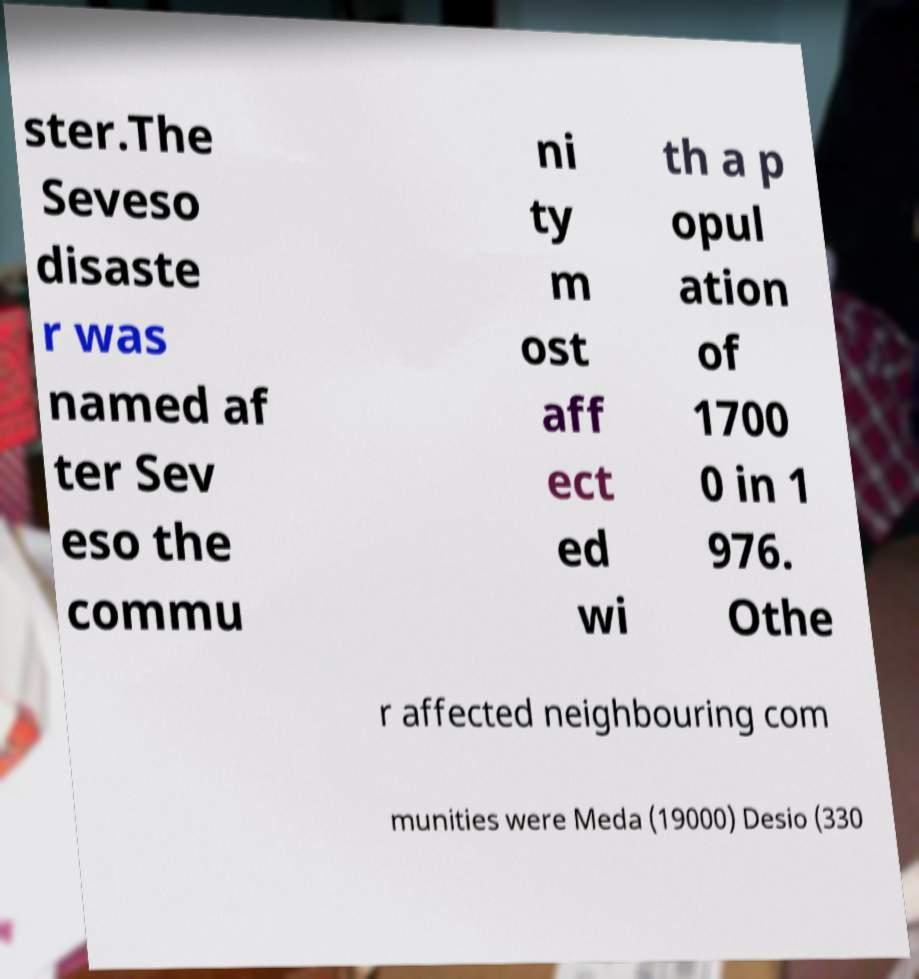Please identify and transcribe the text found in this image. ster.The Seveso disaste r was named af ter Sev eso the commu ni ty m ost aff ect ed wi th a p opul ation of 1700 0 in 1 976. Othe r affected neighbouring com munities were Meda (19000) Desio (330 